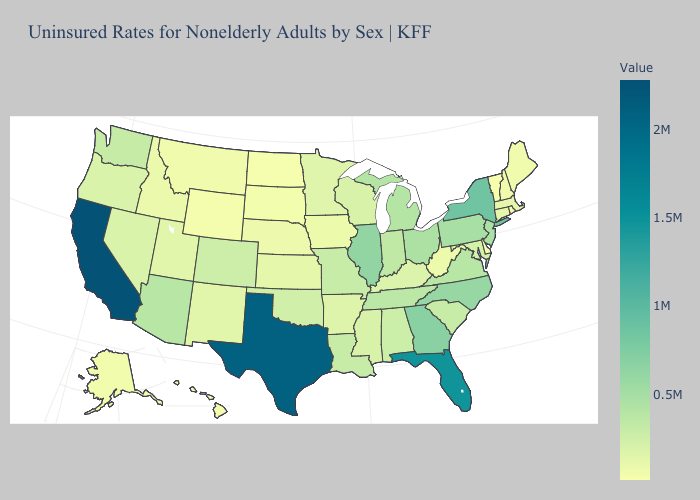Does the map have missing data?
Be succinct. No. Does Kansas have the lowest value in the MidWest?
Keep it brief. No. Which states hav the highest value in the MidWest?
Keep it brief. Illinois. Does the map have missing data?
Give a very brief answer. No. Which states have the lowest value in the MidWest?
Give a very brief answer. North Dakota. 